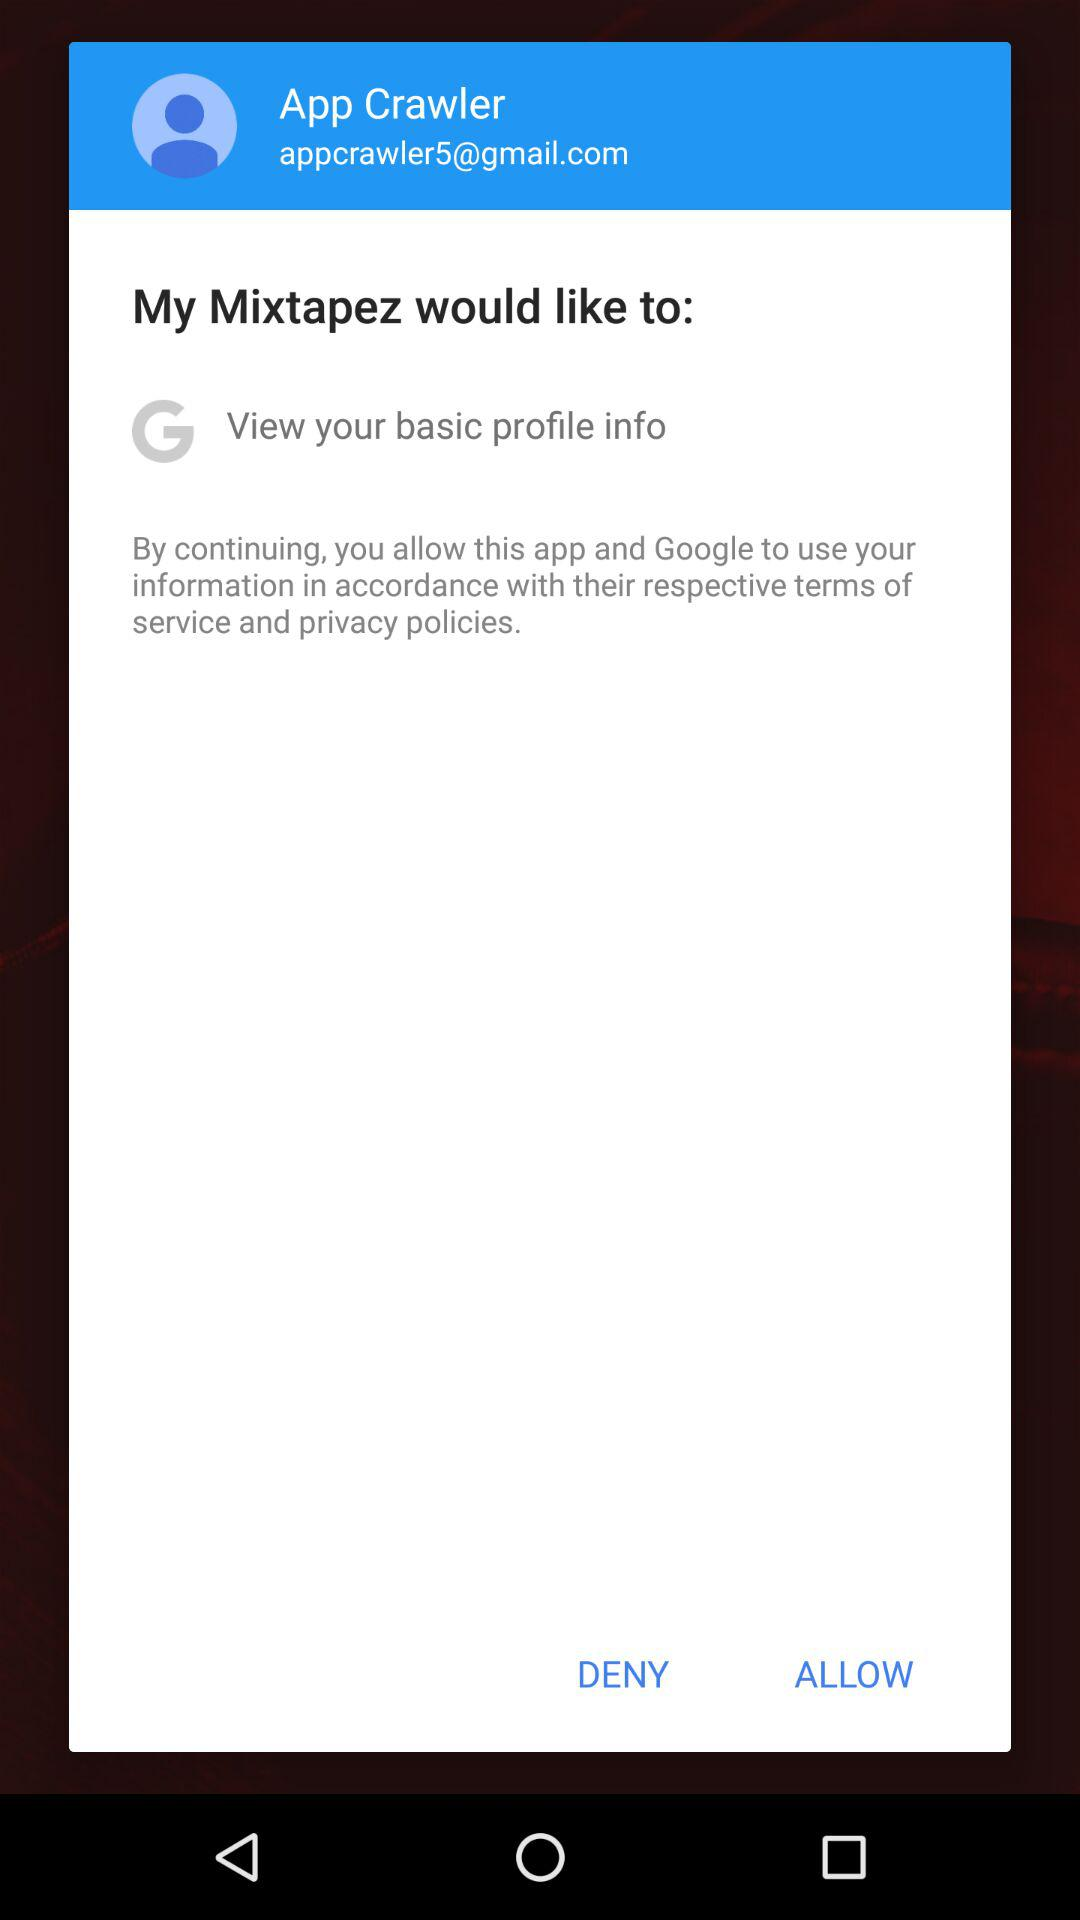Who wants to see basic profile information? The application "My Mixtapez" wants to see basic profile information. 